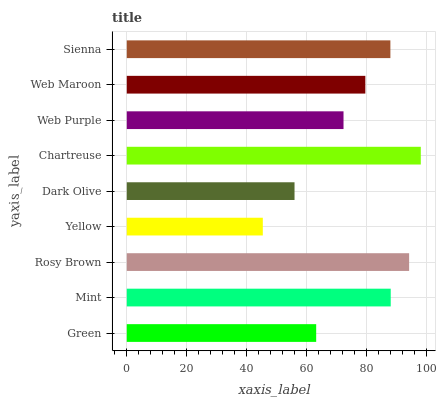Is Yellow the minimum?
Answer yes or no. Yes. Is Chartreuse the maximum?
Answer yes or no. Yes. Is Mint the minimum?
Answer yes or no. No. Is Mint the maximum?
Answer yes or no. No. Is Mint greater than Green?
Answer yes or no. Yes. Is Green less than Mint?
Answer yes or no. Yes. Is Green greater than Mint?
Answer yes or no. No. Is Mint less than Green?
Answer yes or no. No. Is Web Maroon the high median?
Answer yes or no. Yes. Is Web Maroon the low median?
Answer yes or no. Yes. Is Chartreuse the high median?
Answer yes or no. No. Is Green the low median?
Answer yes or no. No. 